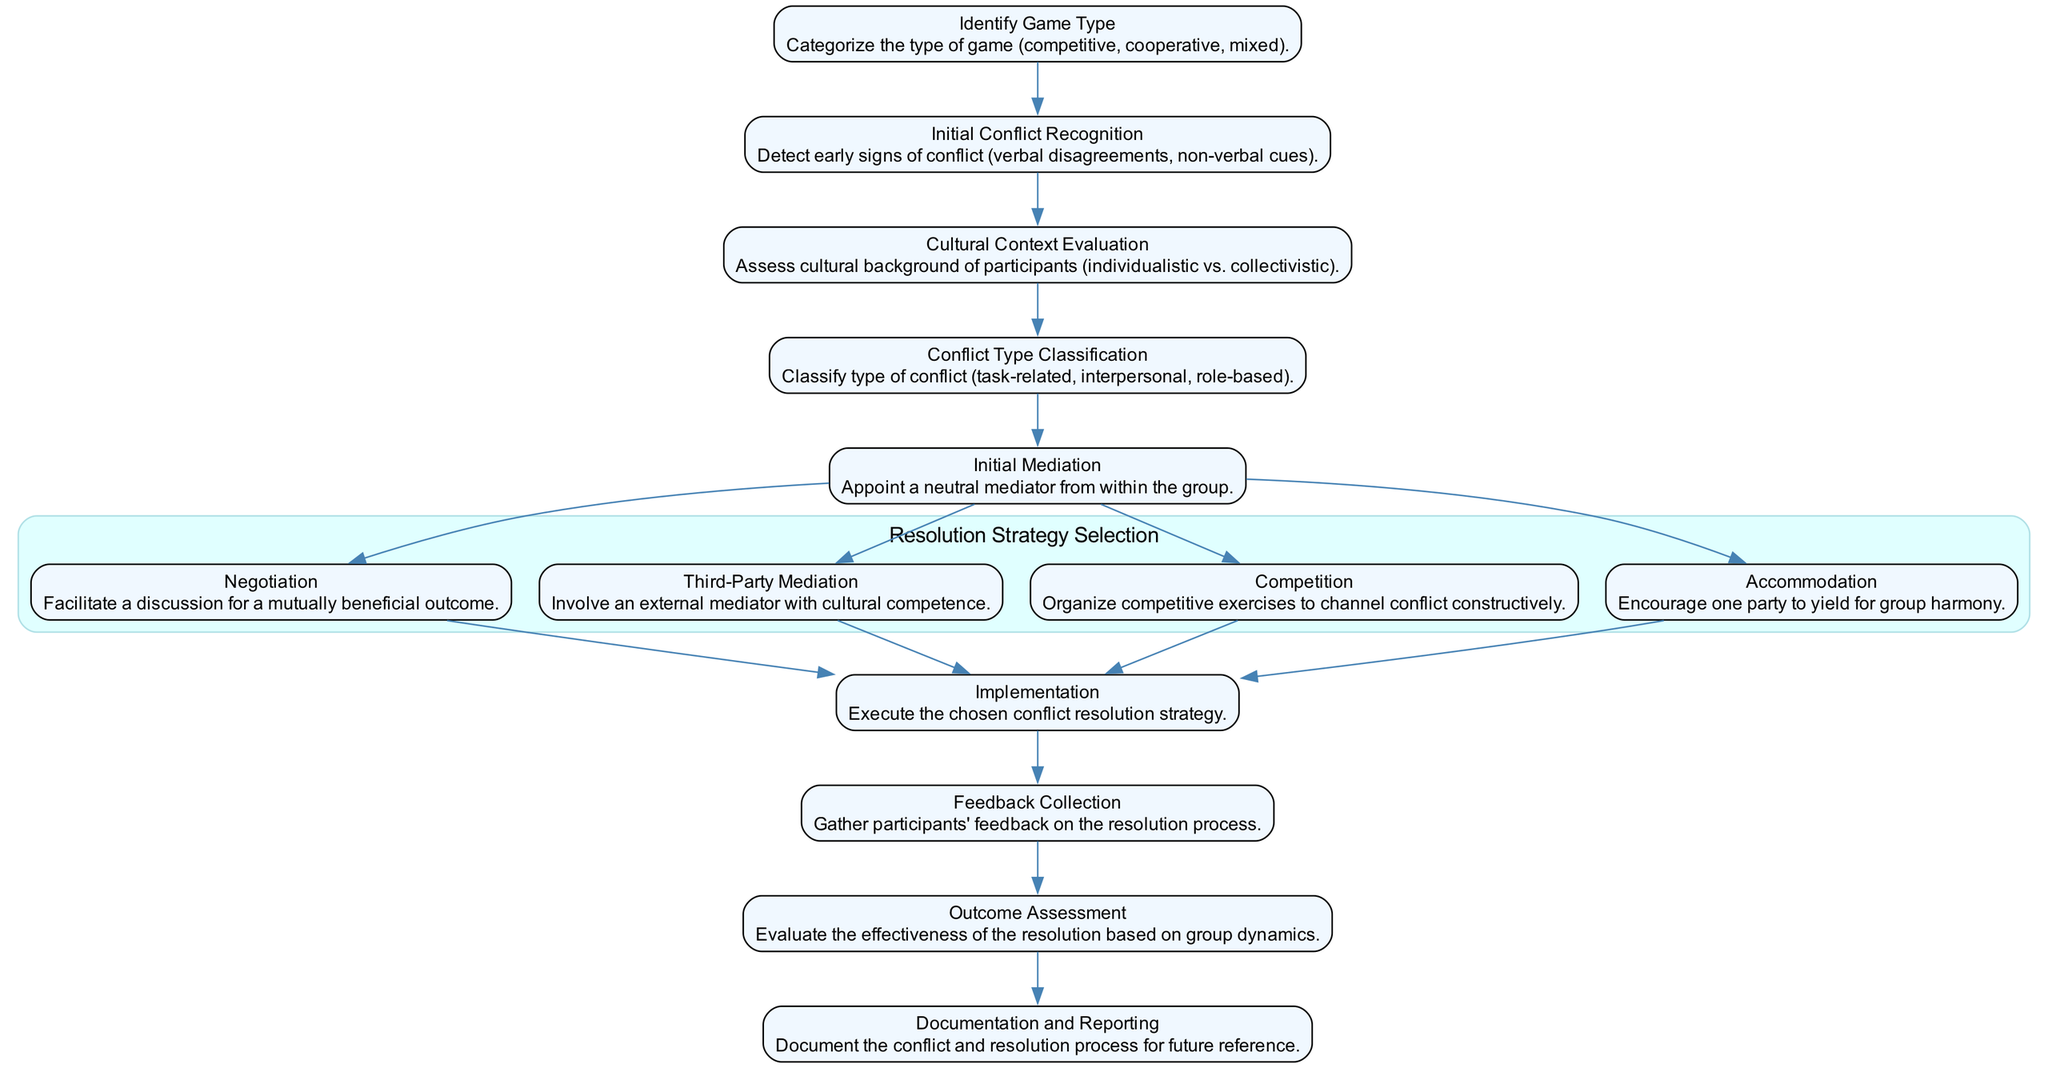What is the first step in the conflict resolution process? The diagram shows that the first step is "Identify Game Type." This is the initial action taken before any conflict recognition can occur.
Answer: Identify Game Type How many resolution strategies are presented in the diagram? By counting the options under "Resolution Strategy Selection," there are four distinct strategies listed: Negotiation, Third-Party Mediation, Competition, and Accommodation.
Answer: 4 What step follows "Initial Conflict Recognition"? The diagram indicates that after "Initial Conflict Recognition," the next step is "Cultural Context Evaluation." This step assesses the cultural background of participants.
Answer: Cultural Context Evaluation Which strategy involves appointing an external mediator? In the options under "Resolution Strategy Selection," the strategy for involving an external mediator is "Third-Party Mediation." This explicitly states that a mediator with cultural competence is involved.
Answer: Third-Party Mediation What is assessed at the "Cultural Context Evaluation"? The description for this step states that it involves assessing the cultural background of participants, focusing on whether they are from individualistic or collectivistic cultures.
Answer: Cultural background of participants What comes after the "Implementation" step? The diagram shows that the step following "Implementation" is "Feedback Collection," which is aimed at gathering participants' insight on the resolution.
Answer: Feedback Collection Which conflict types are classified before selecting a resolution strategy? Prior to the "Resolution Strategy Selection," the diagram lists "Conflict Type Classification," which identifies types such as task-related, interpersonal, and role-based conflicts.
Answer: Task-related, interpersonal, role-based What is the purpose of "Documentation and Reporting"? According to the flowchart, this final step is about documenting the conflict and the resolution process for future reference, ensuring a record exists for analysis or learning.
Answer: Document Which resolution strategy is aimed at facilitating a mutually beneficial outcome? The diagram indicates that the strategy designed to facilitate discussion for a mutually beneficial outcome is "Negotiation." This strategy encourages collaboration between conflicting parties.
Answer: Negotiation 